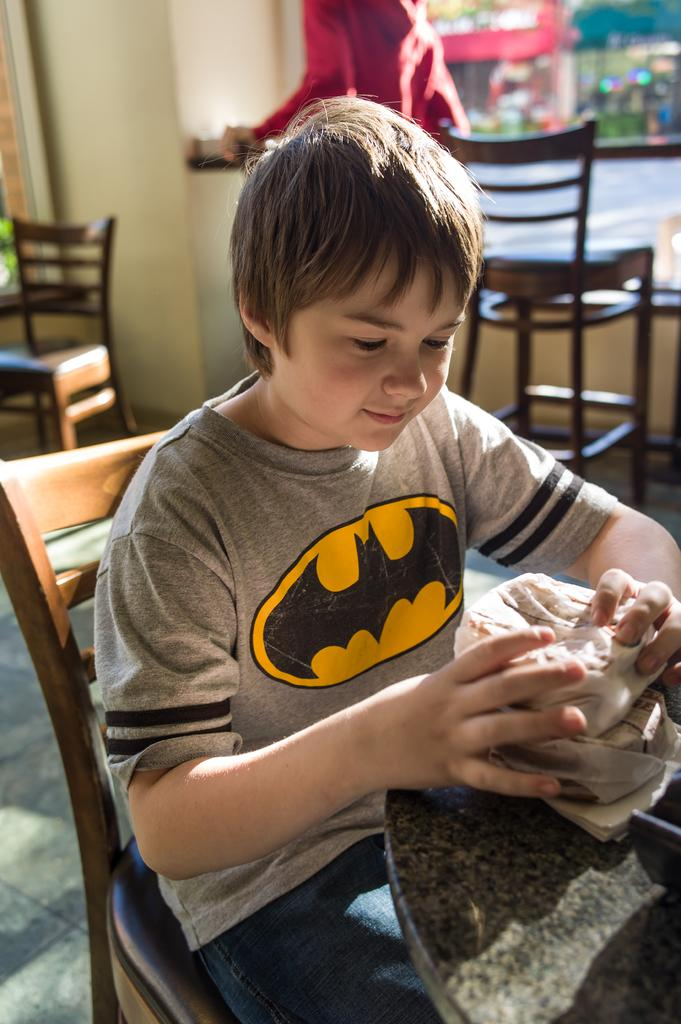Who is the main subject in the image? There is a boy in the image. What is the boy doing in the image? The boy is sitting on a chair and smiling. What is in front of the boy? There is a table in front of the boy. Are there any other chairs visible in the image? Yes, there are chairs in the background of the image. How would you describe the background of the image? The background is blurry. What type of bone is the boy holding in the image? There is no bone present in the image; the boy is sitting on a chair and smiling. 